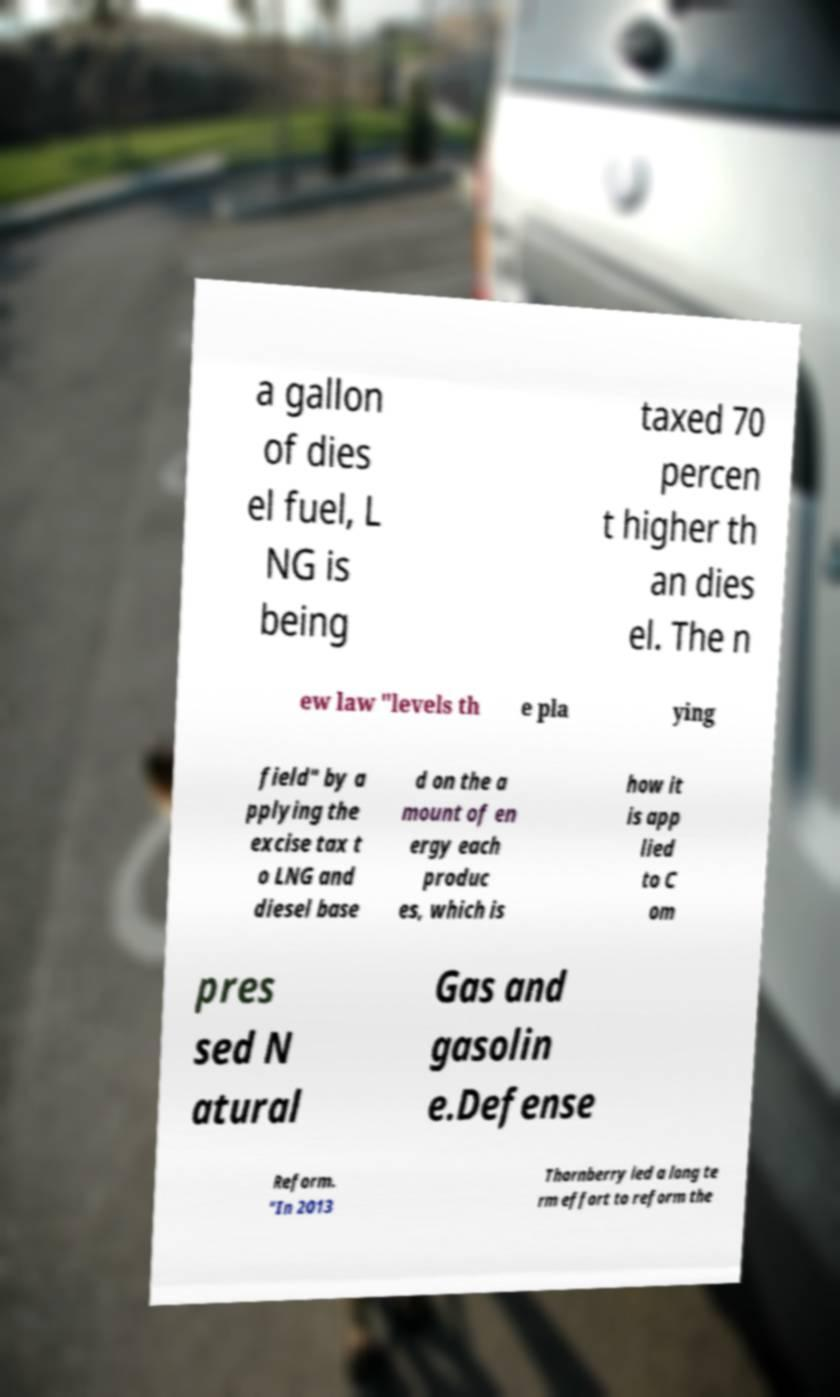Please identify and transcribe the text found in this image. a gallon of dies el fuel, L NG is being taxed 70 percen t higher th an dies el. The n ew law "levels th e pla ying field" by a pplying the excise tax t o LNG and diesel base d on the a mount of en ergy each produc es, which is how it is app lied to C om pres sed N atural Gas and gasolin e.Defense Reform. "In 2013 Thornberry led a long te rm effort to reform the 